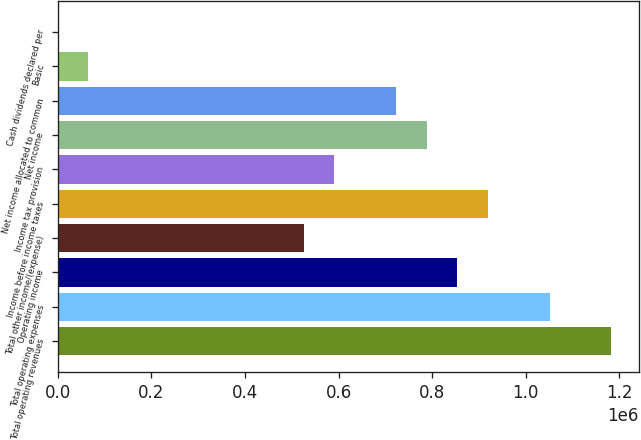Convert chart to OTSL. <chart><loc_0><loc_0><loc_500><loc_500><bar_chart><fcel>Total operating revenues<fcel>Total operating expenses<fcel>Operating income<fcel>Total other income/(expense)<fcel>Income before income taxes<fcel>Income tax provision<fcel>Net income<fcel>Net income allocated to common<fcel>Basic<fcel>Cash dividends declared per<nl><fcel>1.1825e+06<fcel>1.05111e+06<fcel>854029<fcel>525557<fcel>919724<fcel>591251<fcel>788335<fcel>722640<fcel>65695.5<fcel>0.96<nl></chart> 